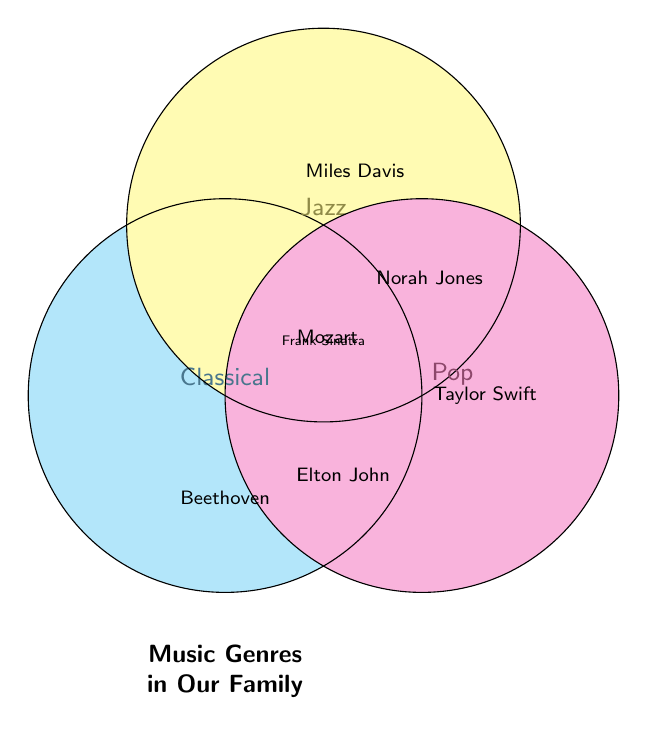Who enjoys Classical music? Look at the section labeled "Classical" within the Venn Diagram. The names listed are Beethoven, Chopin, Bach, and Tchaikovsky.
Answer: Beethoven, Chopin, Bach, Tchaikovsky Which genres does Mozart enjoy? Mozart is positioned in the overlapping area between "Classical" and "Jazz," indicating he enjoys both genres.
Answer: Classical and Jazz Is there anyone who enjoys all three genres? Check the overlapping section of all three circles (Classical, Jazz, and Pop) in the Venn Diagram. Frank Sinatra is listed there.
Answer: Frank Sinatra How many people enjoy Jazz music? Look at the "Jazz" circle, including all unique and overlapping sections. The names listed are Miles Davis, Louis Armstrong, John Coltrane, Ella Fitzgerald, Mozart, Norah Jones, and Frank Sinatra.
Answer: 7 Does Taylor Swift enjoy more than one genre? Taylor Swift is positioned within the "Pop" section and not overlapping with any other circles, indicating she enjoys only Pop.
Answer: No Who enjoys both Classical and Pop music? Check the overlapping section between "Classical" and "Pop." Elton John and Billy Joel are listed there.
Answer: Elton John, Billy Joel Which genre has the least number of unique musicians? Count the number of unique musicians in each genre. Classical: 4 (Beethoven, Chopin, Bach, Tchaikovsky), Jazz: 4 (Miles Davis, Louis Armstrong, John Coltrane, Ella Fitzgerald), Pop: 4 (Taylor Swift, Ed Sheeran, Ariana Grande, Bruno Mars). They are equal.
Answer: All genres have 4 unique musicians Who enjoys both Jazz and Pop music but not Classical? Look at the overlapping section between "Jazz" and "Pop," excluding the section also overlapping with "Classical." Norah Jones and Michael Bublé are listed there.
Answer: Norah Jones, Michael Bublé Which musicians enjoy only one genre? Check the sections that do not overlap with other circles: Beethoven, Chopin, Bach, Tchaikovsky (Classical), Miles Davis, Louis Armstrong, John Coltrane, Ella Fitzgerald (Jazz), Taylor Swift, Ed Sheeran, Ariana Grande, Bruno Mars (Pop).
Answer: 12 musicians 